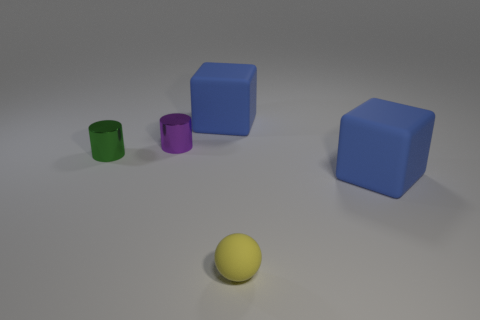Add 5 yellow shiny things. How many objects exist? 10 Subtract all blocks. How many objects are left? 3 Subtract 0 green cubes. How many objects are left? 5 Subtract all green cylinders. Subtract all large blocks. How many objects are left? 2 Add 4 big objects. How many big objects are left? 6 Add 2 small things. How many small things exist? 5 